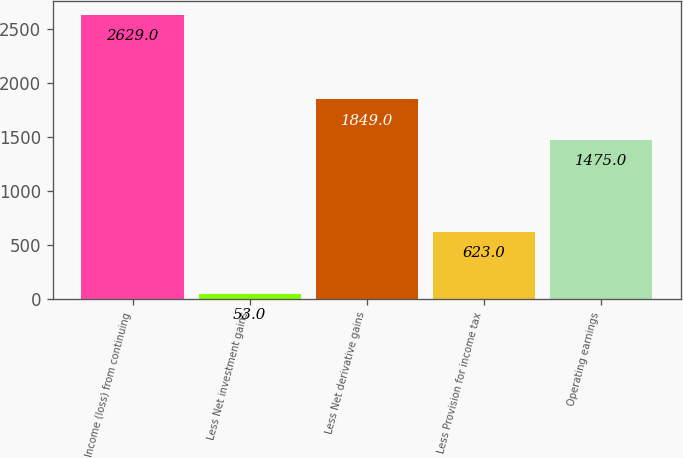<chart> <loc_0><loc_0><loc_500><loc_500><bar_chart><fcel>Income (loss) from continuing<fcel>Less Net investment gains<fcel>Less Net derivative gains<fcel>Less Provision for income tax<fcel>Operating earnings<nl><fcel>2629<fcel>53<fcel>1849<fcel>623<fcel>1475<nl></chart> 